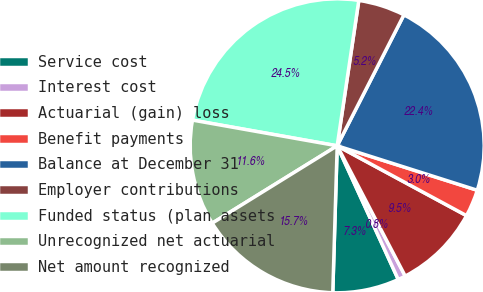<chart> <loc_0><loc_0><loc_500><loc_500><pie_chart><fcel>Service cost<fcel>Interest cost<fcel>Actuarial (gain) loss<fcel>Benefit payments<fcel>Balance at December 31<fcel>Employer contributions<fcel>Funded status (plan assets<fcel>Unrecognized net actuarial<fcel>Net amount recognized<nl><fcel>7.3%<fcel>0.84%<fcel>9.46%<fcel>2.99%<fcel>22.39%<fcel>5.15%<fcel>24.55%<fcel>11.62%<fcel>15.7%<nl></chart> 